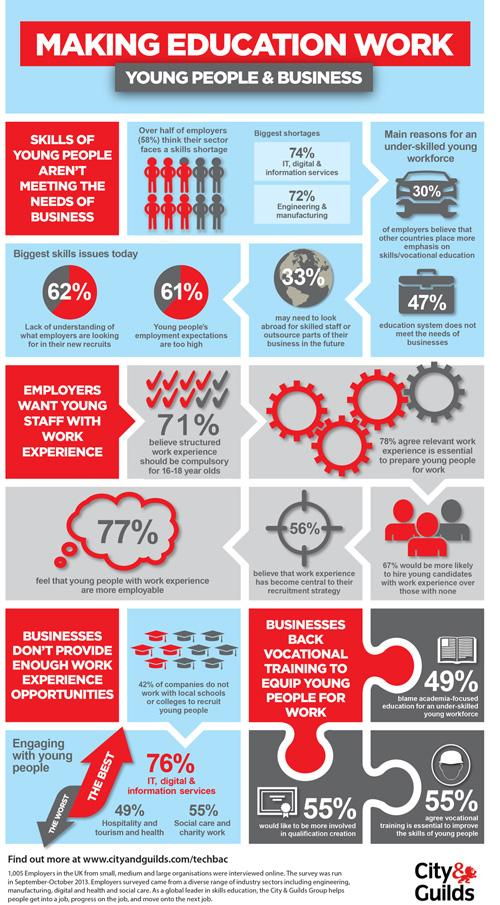Outline some significant characteristics in this image. According to the provided data, 58% of companies work with local schools or colleges to recruit young people. According to the survey, 44% believe that work experience is no longer a central factor in their recruitment strategy. According to a recent survey, 53% of the education system effectively meets the needs of businesses. 